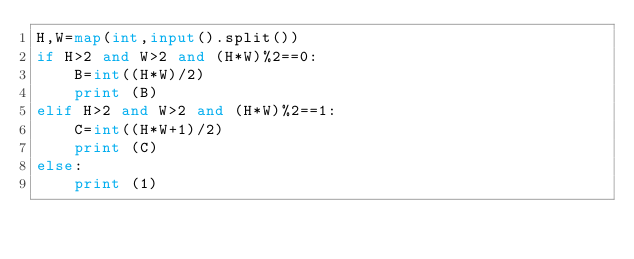<code> <loc_0><loc_0><loc_500><loc_500><_Python_>H,W=map(int,input().split())
if H>2 and W>2 and (H*W)%2==0:
    B=int((H*W)/2)
    print (B)
elif H>2 and W>2 and (H*W)%2==1:
    C=int((H*W+1)/2)
    print (C)
else:
    print (1)</code> 